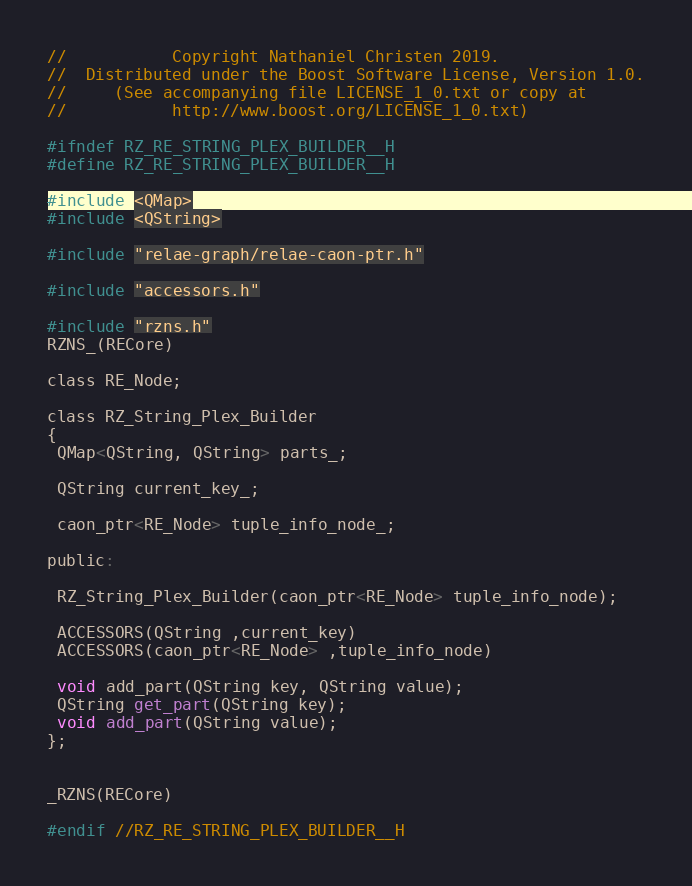Convert code to text. <code><loc_0><loc_0><loc_500><loc_500><_C_>
//           Copyright Nathaniel Christen 2019.
//  Distributed under the Boost Software License, Version 1.0.
//     (See accompanying file LICENSE_1_0.txt or copy at
//           http://www.boost.org/LICENSE_1_0.txt)

#ifndef RZ_RE_STRING_PLEX_BUILDER__H
#define RZ_RE_STRING_PLEX_BUILDER__H

#include <QMap>
#include <QString>

#include "relae-graph/relae-caon-ptr.h"

#include "accessors.h"

#include "rzns.h"
RZNS_(RECore)

class RE_Node;

class RZ_String_Plex_Builder
{
 QMap<QString, QString> parts_;

 QString current_key_;

 caon_ptr<RE_Node> tuple_info_node_;

public:

 RZ_String_Plex_Builder(caon_ptr<RE_Node> tuple_info_node);

 ACCESSORS(QString ,current_key)
 ACCESSORS(caon_ptr<RE_Node> ,tuple_info_node)

 void add_part(QString key, QString value);
 QString get_part(QString key);
 void add_part(QString value);
};


_RZNS(RECore)

#endif //RZ_RE_STRING_PLEX_BUILDER__H



</code> 